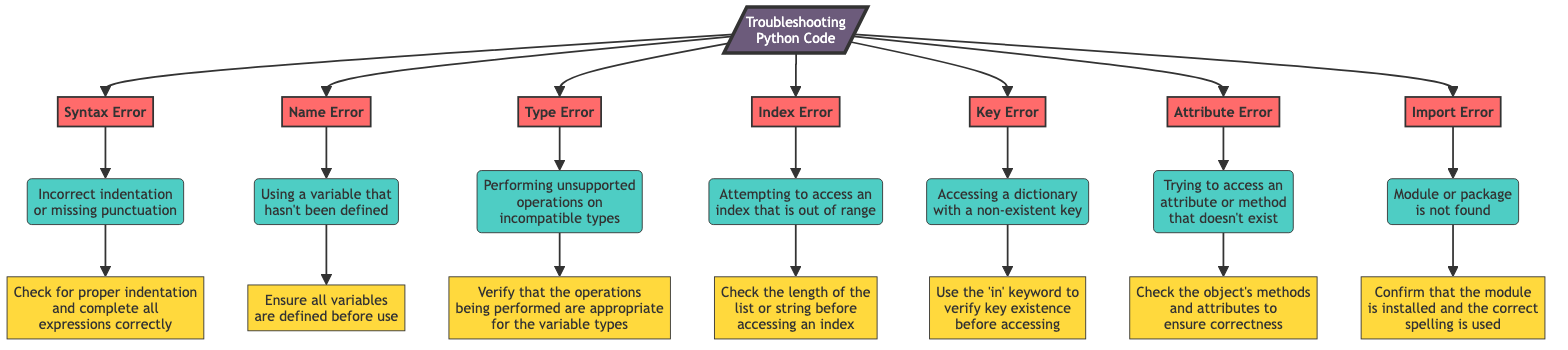What is the first error listed in the flow chart? The flow chart begins with the "Syntax Error," which is the first error node that branches out from the "Start" node.
Answer: Syntax Error How many errors are detailed in the flow chart? There are a total of seven error nodes present in the flow chart: Syntax Error, Name Error, Type Error, Index Error, Key Error, Attribute Error, and Import Error.
Answer: 7 What cause is associated with the Name Error? The cause associated with the Name Error is "Using a variable that hasn't been defined," which directly connects to the Name Error node in the flow chart.
Answer: Using a variable that hasn't been defined Which suggested fix is linked to the Index Error? The suggested fix linked to the Index Error is "Check the length of the list or string before accessing an index," indicating the corrective action for that error.
Answer: Check the length of the list or string before accessing an index If you encounter a Type Error, what should you verify? If a Type Error is encountered, you should verify "that the operations being performed are appropriate for the variable types," as indicated in the flow chart's suggested fixes.
Answer: That the operations being performed are appropriate for the variable types Which error suggestion involves checking an object's methods? The suggestion that involves checking an object's methods pertains to the Attribute Error, where you must "Check the object's methods and attributes to ensure correctness."
Answer: Check the object's methods and attributes to ensure correctness What connects the Syntax Error to its suggested fix in the flow chart? The connection from the Syntax Error to its suggested fix is made through the cause "Incorrect indentation or missing punctuation," which flows from the Syntax Error node to the fix node.
Answer: Incorrect indentation or missing punctuation Which keyword should be used when accessing a dictionary to avoid a Key Error? To avoid a Key Error when accessing a dictionary, you should use the "in" keyword to verify key existence before accessing, as detailed in the flow chart.
Answer: in 